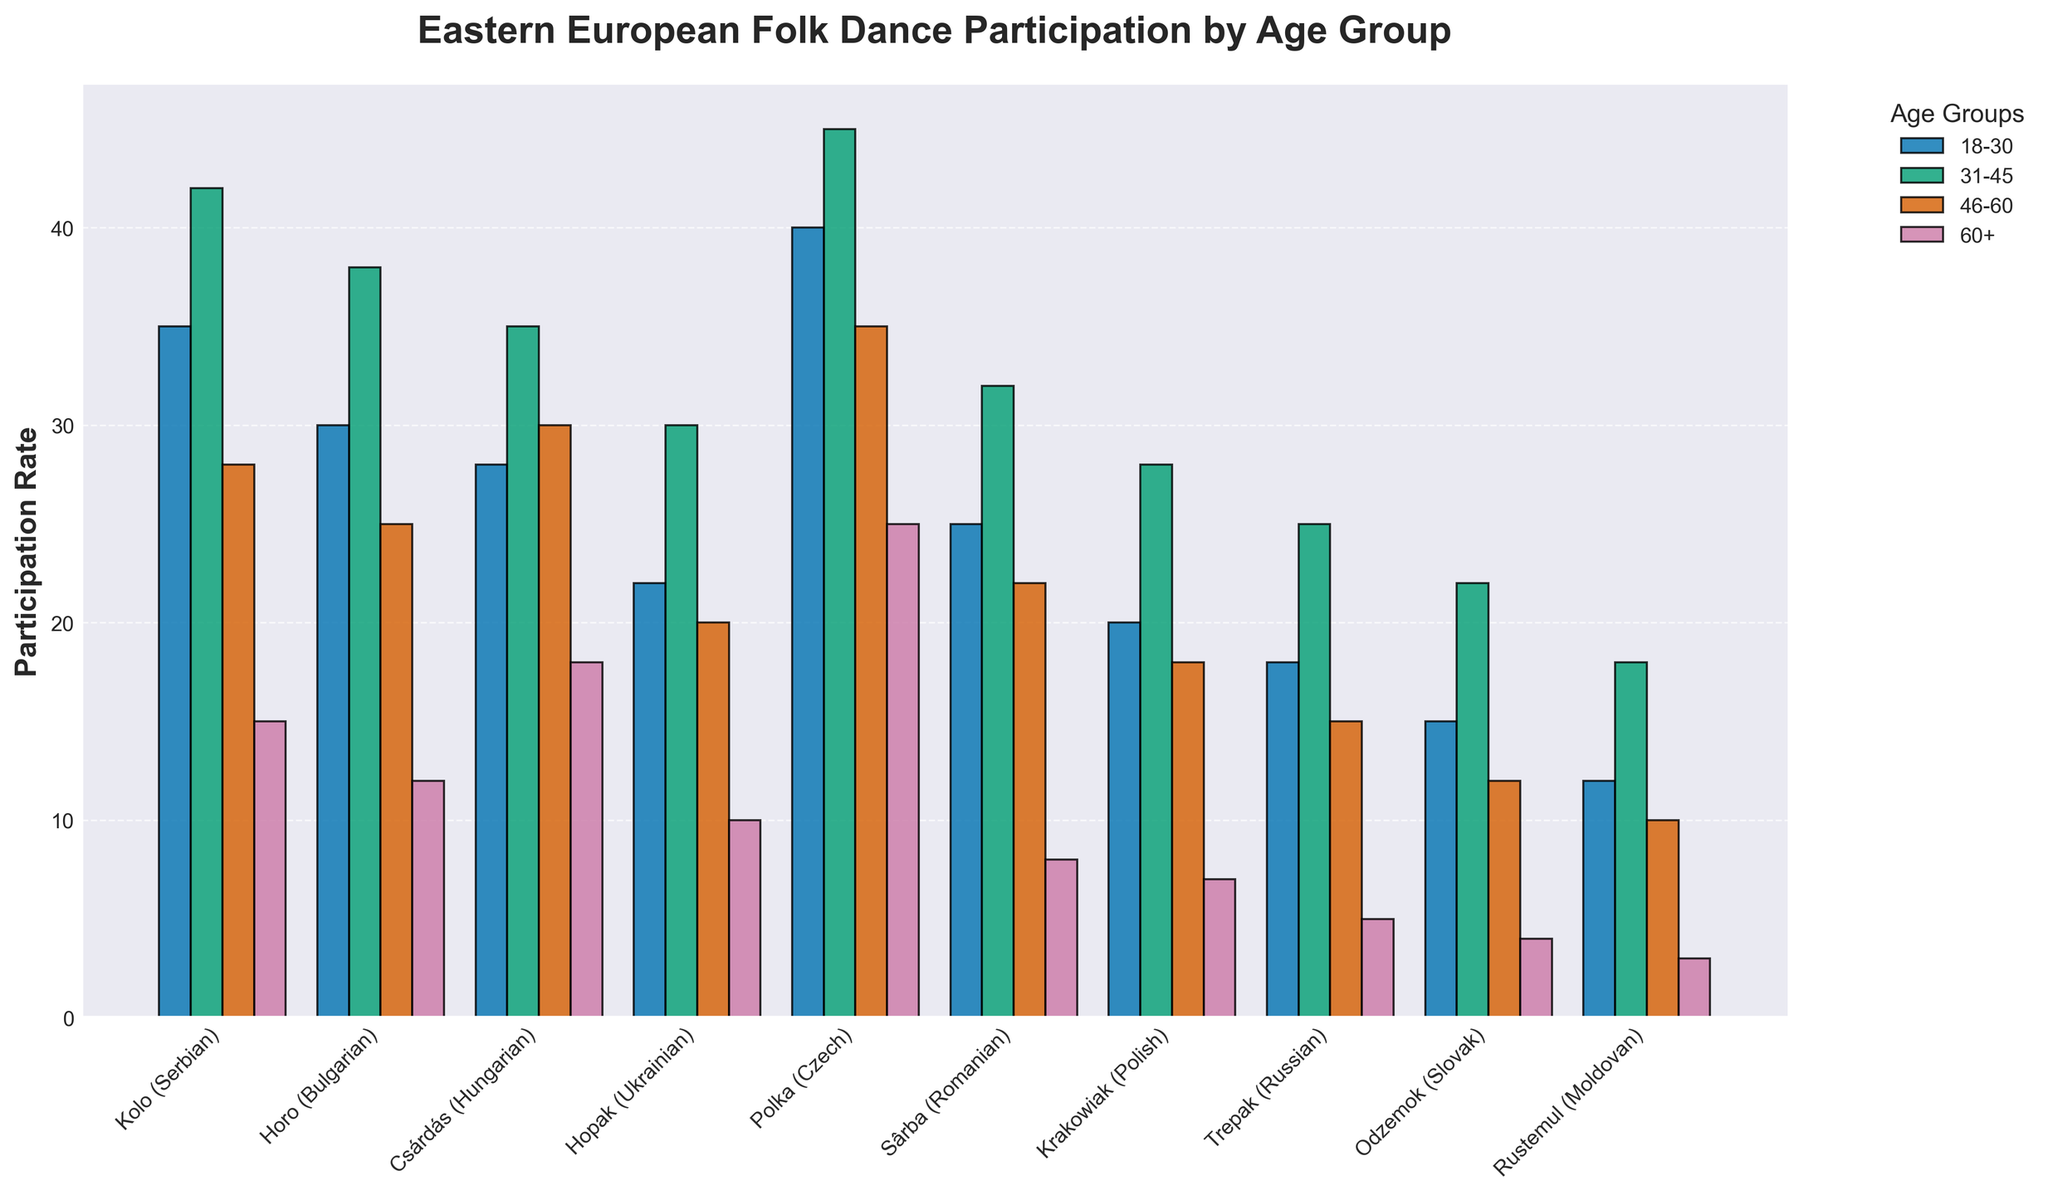Which age group has the highest participation rate in the Csárdás dance? The Csárdás dance has the highest bar for the 31-45 age group compared to other age groups.
Answer: 31-45 What is the difference in participation rates between the Polka and Hopak dances for the 60+ age group? The participation rate for Polka in the 60+ age group is 25, while for Hopak it is 10. The difference is 25 - 10.
Answer: 15 Which dance has the lowest participation rate among the 18-30 age group? The smallest bar for the 18-30 age group is for the Rustemul dance.
Answer: Rustemul By how much does the participation rate of the 18-30 age group for Kolo exceed that for Trepak? The participation rate for Kolo is 35, and for Trepak, it is 18. The difference is 35 - 18.
Answer: 17 What is the average participation rate for the age group 46-60 across all dances? Sum the participation rates for 46-60: 28 + 25 + 30 + 20 + 35 + 22 + 18 + 15 + 12 + 10 = 215. The total number of dances is 10. 215 / 10 = 21.5.
Answer: 21.5 Which dance shows the largest decline in participation rate from the 18-30 age group to the 60+ age group? Calculate the difference for each dance:
Kolo (35-15=20), Horo (30-12=18), Csárdás (28-18=10), Hopak (22-10=12), Polka (40-25=15), Sârba (25-8=17), Krakowiak (20-7=13), Trepak (18-5=13), Odzemok (15-4=11), Rustemul (12-3=9). The largest decline is in Kolo with 20.
Answer: Kolo How does the participation rate for the 31-45 age group compare between Horo and Sârba? The participation rate for Horo is 38, while for Sârba it is 32. Horo > Sârba.
Answer: Horo For which age group is the participation rate in Polka the highest? The highest bar for Polka among all age groups is observed in the 31-45 age group.
Answer: 31-45 What is the total participation rate for the Odzemok dance across all age groups? Sum the participation rates for Odzemok across all age groups: 15 + 22 + 12 + 4 = 53.
Answer: 53 Which dance has the most similar participation rates between the 18-30 and 31-45 age groups? Kolo: 35 vs 42 (difference of 7), Horo: 30 vs 38 (8), Csárdás: 28 vs 35 (7), Hopak: 22 vs 30 (8), Polka: 40 vs 45 (5), Sârba: 25 vs 32 (7), Krakowiak: 20 vs 28 (8), Trepak: 18 vs 25 (7), Odzemok: 15 vs 22 (7), Rustemul: 12 vs 18 (6). Polka has the most similar rates.
Answer: Polka 